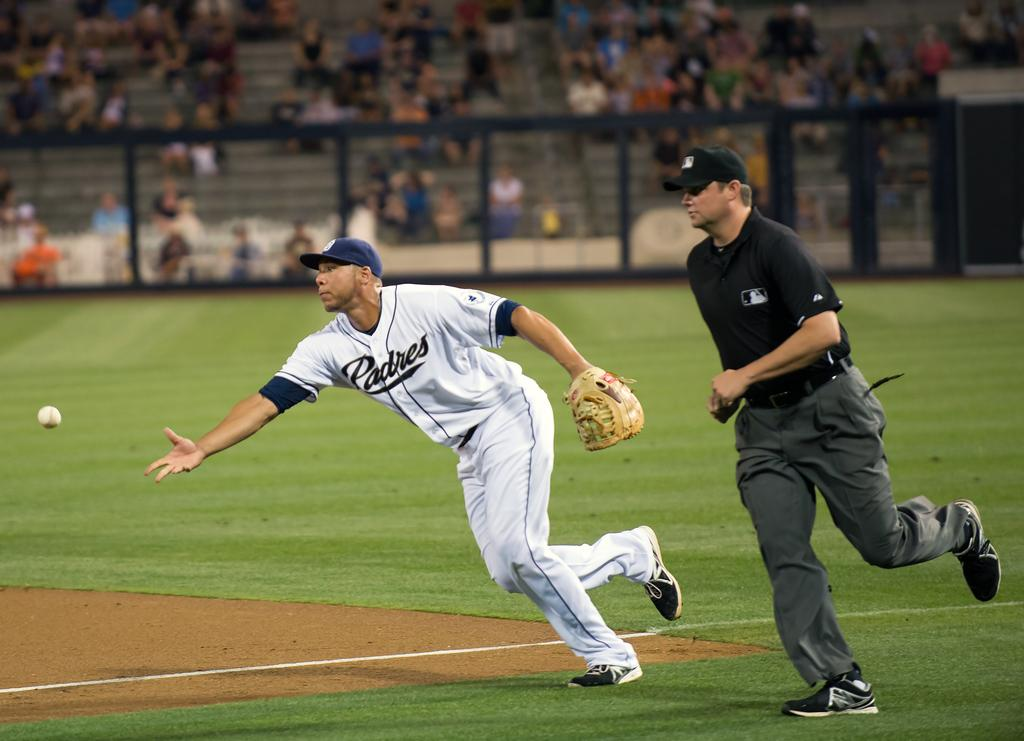<image>
Summarize the visual content of the image. A Padres fielder throws a baseball during a play in a game. 